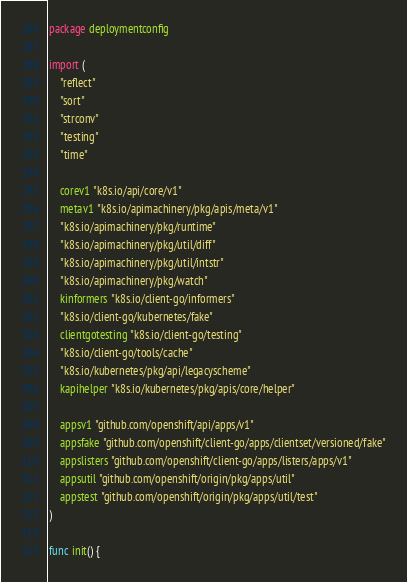Convert code to text. <code><loc_0><loc_0><loc_500><loc_500><_Go_>package deploymentconfig

import (
	"reflect"
	"sort"
	"strconv"
	"testing"
	"time"

	corev1 "k8s.io/api/core/v1"
	metav1 "k8s.io/apimachinery/pkg/apis/meta/v1"
	"k8s.io/apimachinery/pkg/runtime"
	"k8s.io/apimachinery/pkg/util/diff"
	"k8s.io/apimachinery/pkg/util/intstr"
	"k8s.io/apimachinery/pkg/watch"
	kinformers "k8s.io/client-go/informers"
	"k8s.io/client-go/kubernetes/fake"
	clientgotesting "k8s.io/client-go/testing"
	"k8s.io/client-go/tools/cache"
	"k8s.io/kubernetes/pkg/api/legacyscheme"
	kapihelper "k8s.io/kubernetes/pkg/apis/core/helper"

	appsv1 "github.com/openshift/api/apps/v1"
	appsfake "github.com/openshift/client-go/apps/clientset/versioned/fake"
	appslisters "github.com/openshift/client-go/apps/listers/apps/v1"
	appsutil "github.com/openshift/origin/pkg/apps/util"
	appstest "github.com/openshift/origin/pkg/apps/util/test"
)

func init() {</code> 